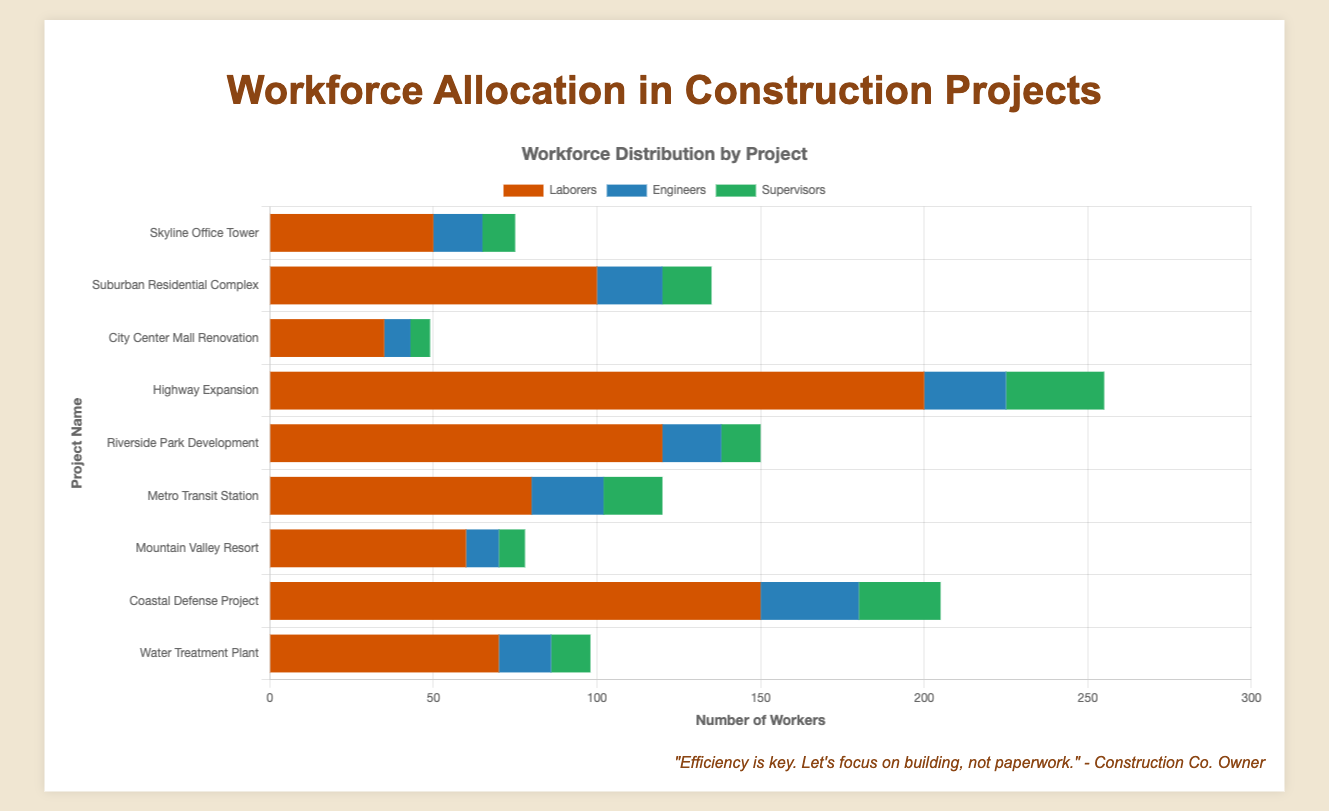Which project has the highest number of laborers? By examining the heights of the orange bars representing laborers, we see that the "Highway Expansion" project has the tallest bar, indicating it has the highest number of laborers.
Answer: Highway Expansion Which project has more engineers: Skyline Office Tower or Metro Transit Station? Comparing the blue bars for both projects, the Metro Transit Station's blue bar is taller than Skyline Office Tower's, indicating that Metro Transit Station has more engineers.
Answer: Metro Transit Station What is the total number of laborers in the Suburban Residential Complex and Coastal Defense Project combined? Adding the number of laborers from both projects: Suburban Residential Complex (100) + Coastal Defense Project (150) equates to 250 laborers.
Answer: 250 Which project has the least number of supervisors? By looking at the height of green bars representing supervisors, the "City Center Mall Renovation" has the shortest green bar, thus the fewest number of supervisors.
Answer: City Center Mall Renovation What's the total workforce dedicated to the Highway Expansion project? Summing all workforce allocations for the Highway Expansion: Laborers (200) + Engineers (25) + Supervisors (30) totals to 255 workers.
Answer: 255 How does the number of laborers in Mountain Valley Resort compare to Water Treatment Plant? The orange bar representing laborers for Mountain Valley Resort is taller than that of Water Treatment Plant, indicating more laborers in Mountain Valley Resort.
Answer: Mountain Valley Resort What is the average number of engineers across all projects? Summing all the engineers across the projects (15 + 20 + 8 + 25 + 18 + 22 + 10 + 30 + 16 = 164), then dividing by the number of projects (9), the average is 164/9 ≈ 18.22.
Answer: 18.22 Which project has the greatest total number of supervisors and engineers combined? Adding supervisors and engineers for each project and comparing:
- Skyline Office Tower: 10 + 15 = 25
- Suburban Residential Complex: 15 + 20 = 35
- City Center Mall Renovation: 6 + 8 = 14
- Highway Expansion: 30 + 25 = 55
- Riverside Park Development: 12 + 18 = 30
- Metro Transit Station: 18 + 22 = 40
- Mountain Valley Resort: 8 + 10 = 18
- Coastal Defense Project: 25 + 30 = 55
- Water Treatment Plant: 12 + 16 = 28
The Coastal Defense Project and Highway Expansion both have the greatest combined total of 55 each.
Answer: Coastal Defense Project and Highway Expansion 